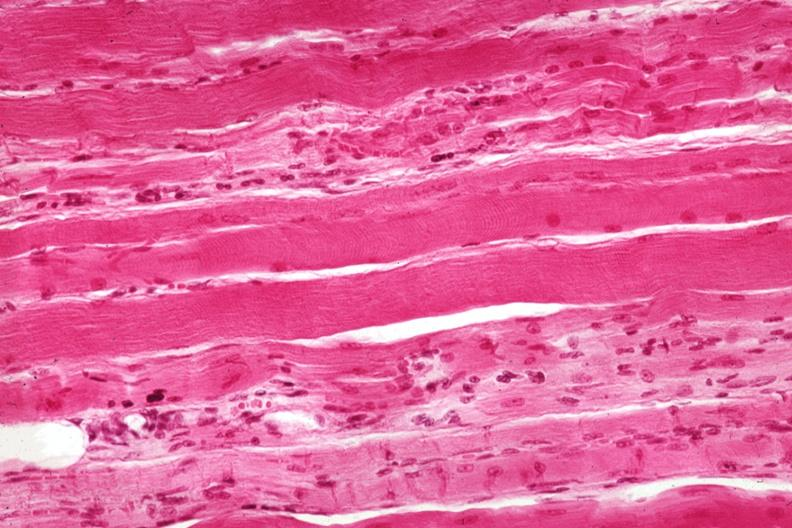s carcinoma superficial spreading present?
Answer the question using a single word or phrase. No 